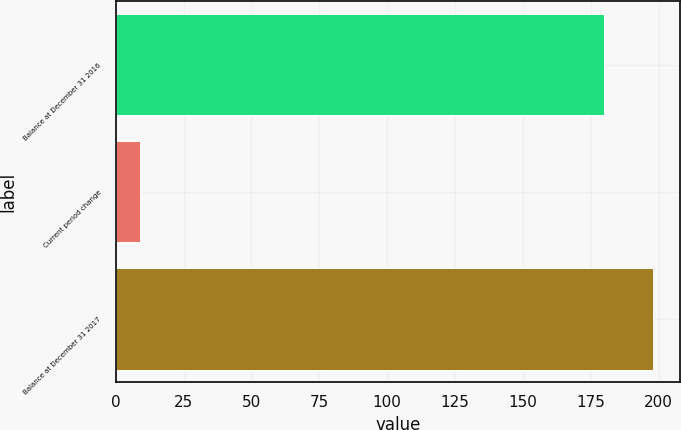Convert chart to OTSL. <chart><loc_0><loc_0><loc_500><loc_500><bar_chart><fcel>Balance at December 31 2016<fcel>Current period change<fcel>Balance at December 31 2017<nl><fcel>180<fcel>9<fcel>198<nl></chart> 